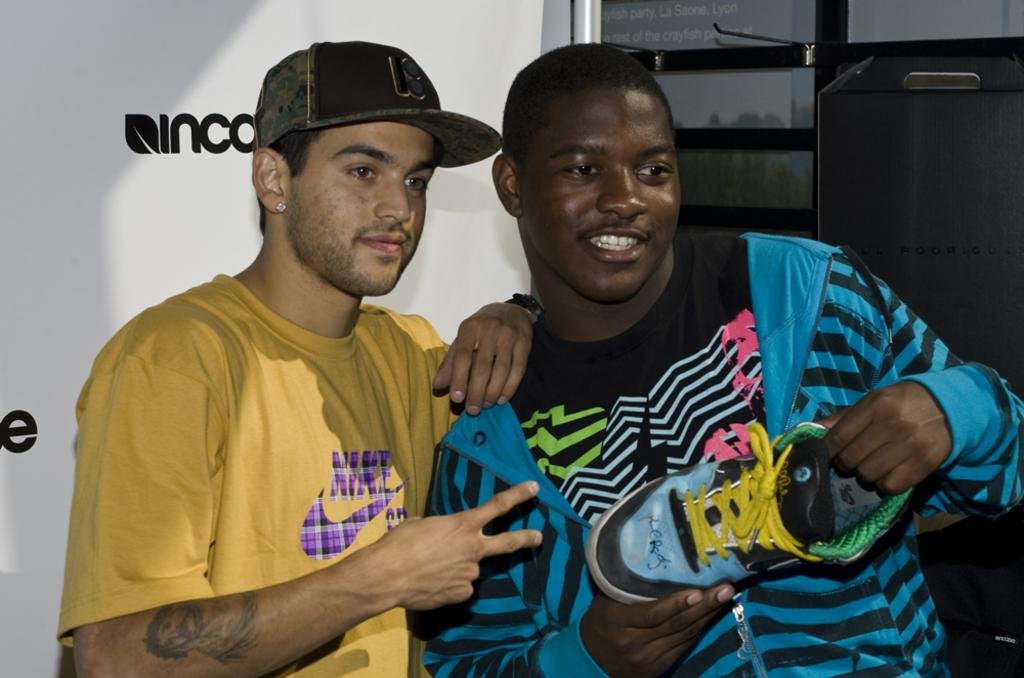<image>
Provide a brief description of the given image. A black man holding a shoe is standing next to a white man with a yellow Nike shirt. 